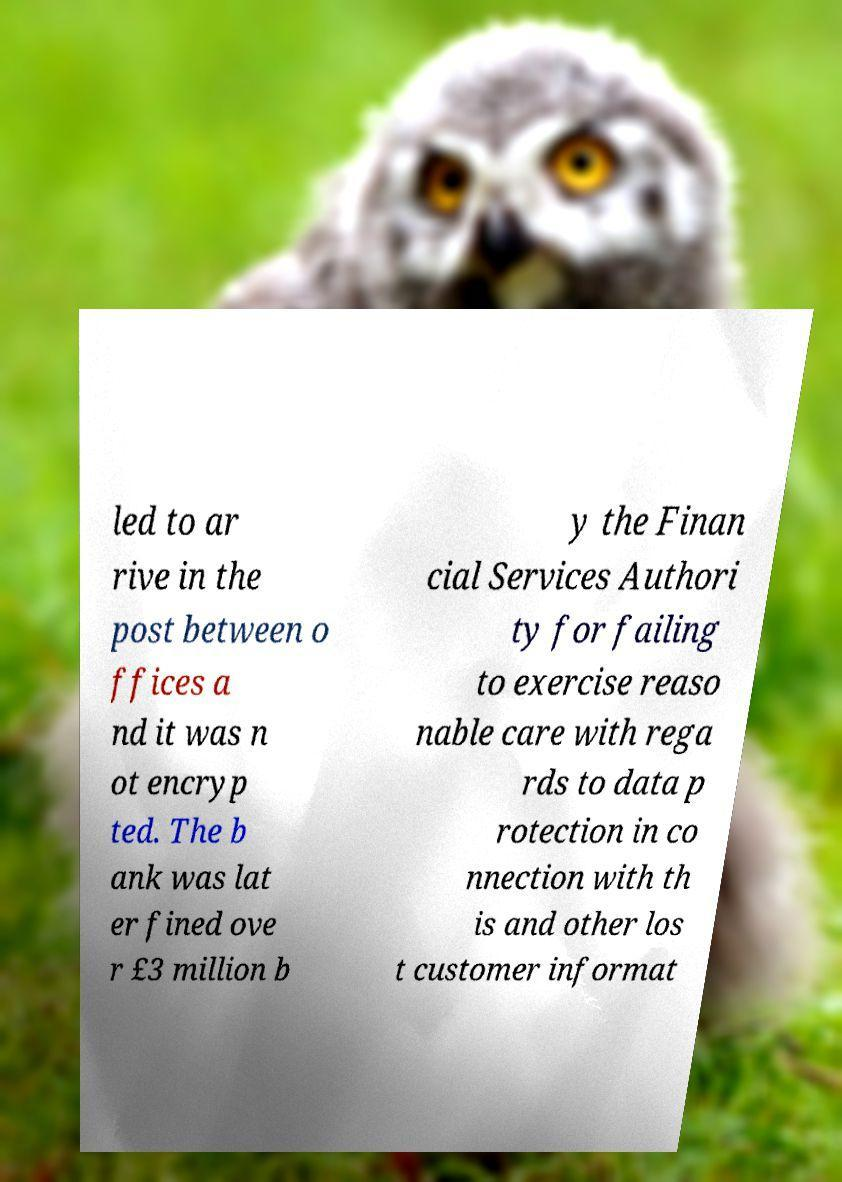Can you accurately transcribe the text from the provided image for me? led to ar rive in the post between o ffices a nd it was n ot encryp ted. The b ank was lat er fined ove r £3 million b y the Finan cial Services Authori ty for failing to exercise reaso nable care with rega rds to data p rotection in co nnection with th is and other los t customer informat 